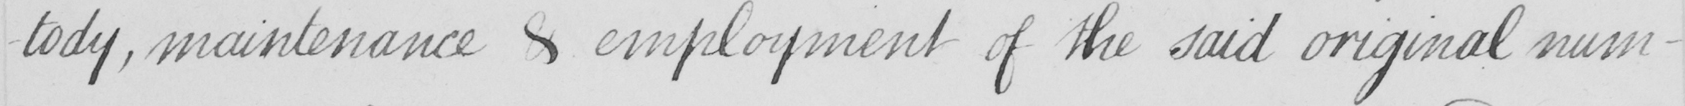Can you tell me what this handwritten text says? -tody , maintenance & employment of the said original num- 